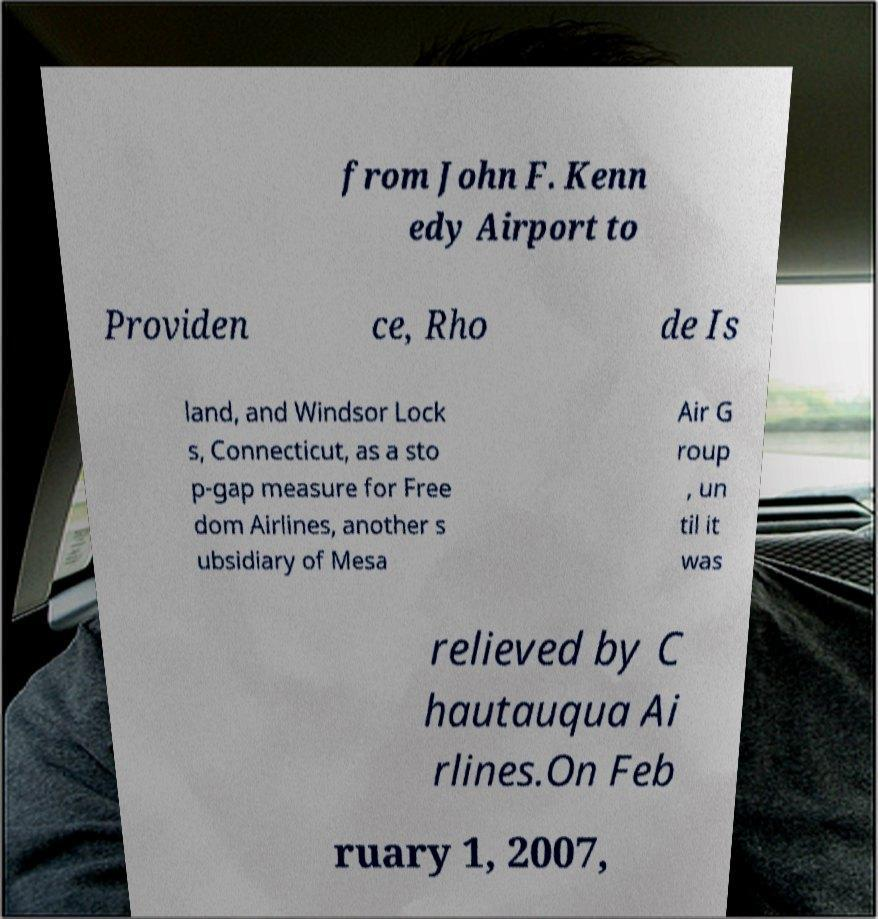For documentation purposes, I need the text within this image transcribed. Could you provide that? from John F. Kenn edy Airport to Providen ce, Rho de Is land, and Windsor Lock s, Connecticut, as a sto p-gap measure for Free dom Airlines, another s ubsidiary of Mesa Air G roup , un til it was relieved by C hautauqua Ai rlines.On Feb ruary 1, 2007, 